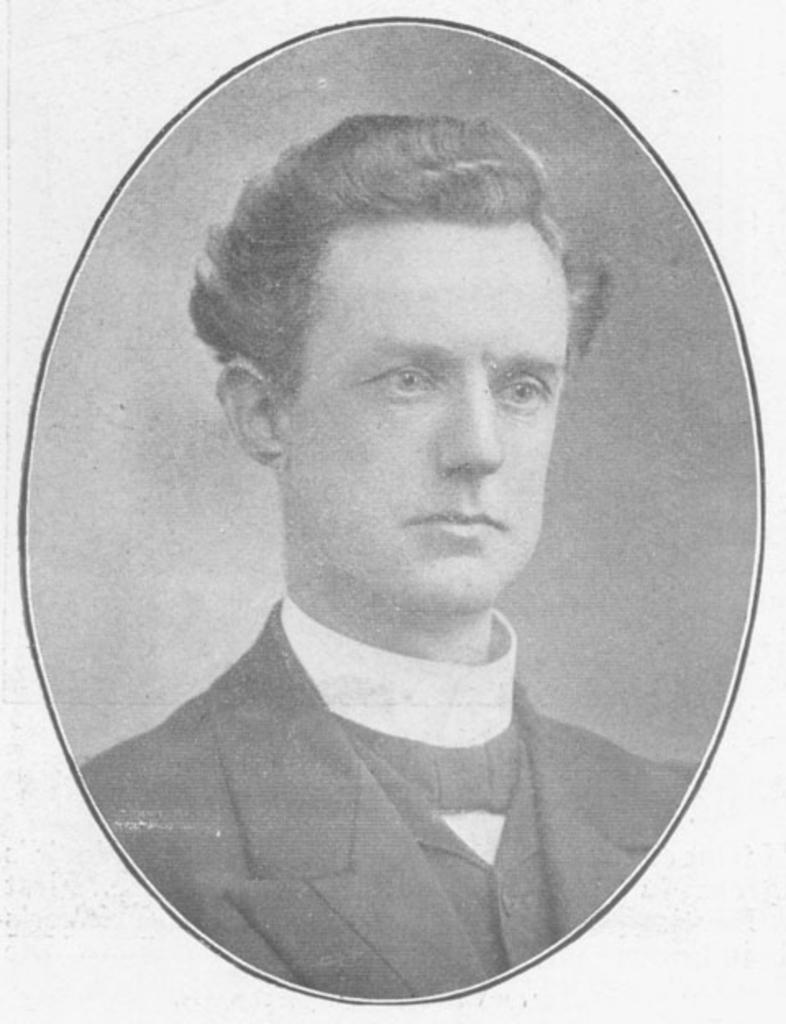Please provide a concise description of this image. This is a black and white picture and in this picture we can see a man wore a blazer. 